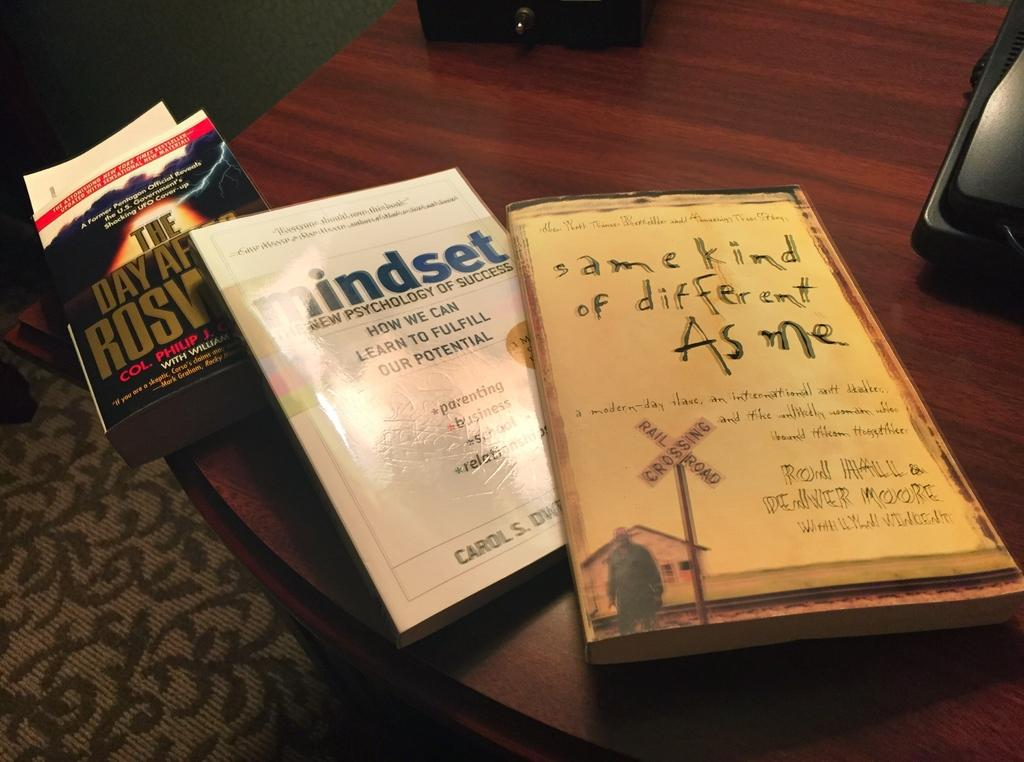<image>
Describe the image concisely. A book called Mindset is in the middle of two other books. 